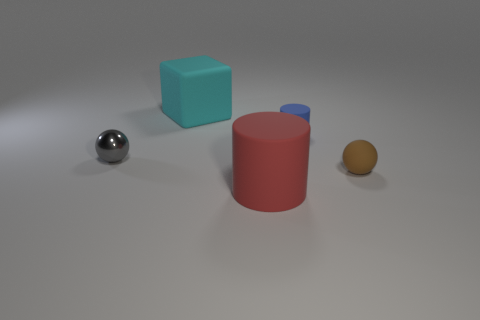How many other objects are the same color as the big rubber cylinder?
Offer a very short reply. 0. There is a rubber object right of the blue object; does it have the same size as the matte object that is behind the blue matte object?
Keep it short and to the point. No. Are there an equal number of big matte cylinders that are behind the tiny gray metal ball and small metallic balls right of the cyan rubber cube?
Keep it short and to the point. Yes. Are there any other things that are made of the same material as the cyan cube?
Offer a terse response. Yes. Is the size of the gray object the same as the matte thing left of the red rubber thing?
Make the answer very short. No. What is the material of the large thing that is behind the rubber cylinder in front of the small blue cylinder?
Ensure brevity in your answer.  Rubber. Are there an equal number of rubber objects that are on the right side of the blue matte object and large metal cubes?
Ensure brevity in your answer.  No. How big is the rubber thing that is both in front of the large cyan rubber thing and behind the tiny metallic sphere?
Make the answer very short. Small. What color is the big matte thing that is to the right of the object that is behind the small cylinder?
Provide a short and direct response. Red. What number of red things are cylinders or rubber spheres?
Your response must be concise. 1. 